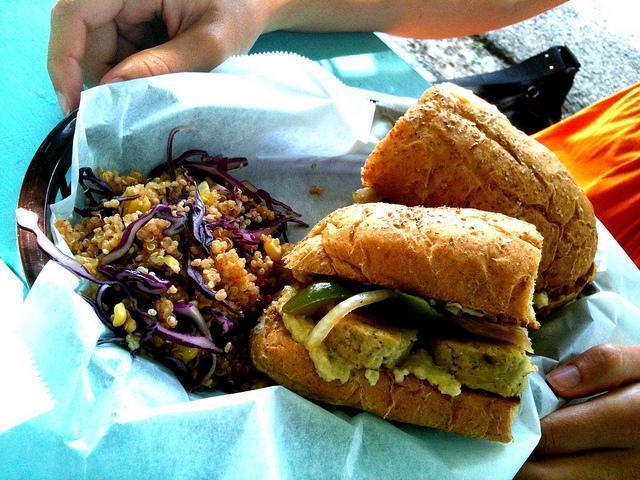What type of food is shown?
Indicate the correct choice and explain in the format: 'Answer: answer
Rationale: rationale.'
Options: Soup, fruit, sandwiches, donuts. Answer: sandwiches.
Rationale: Vegetables and other ingredients are being served on bread. 